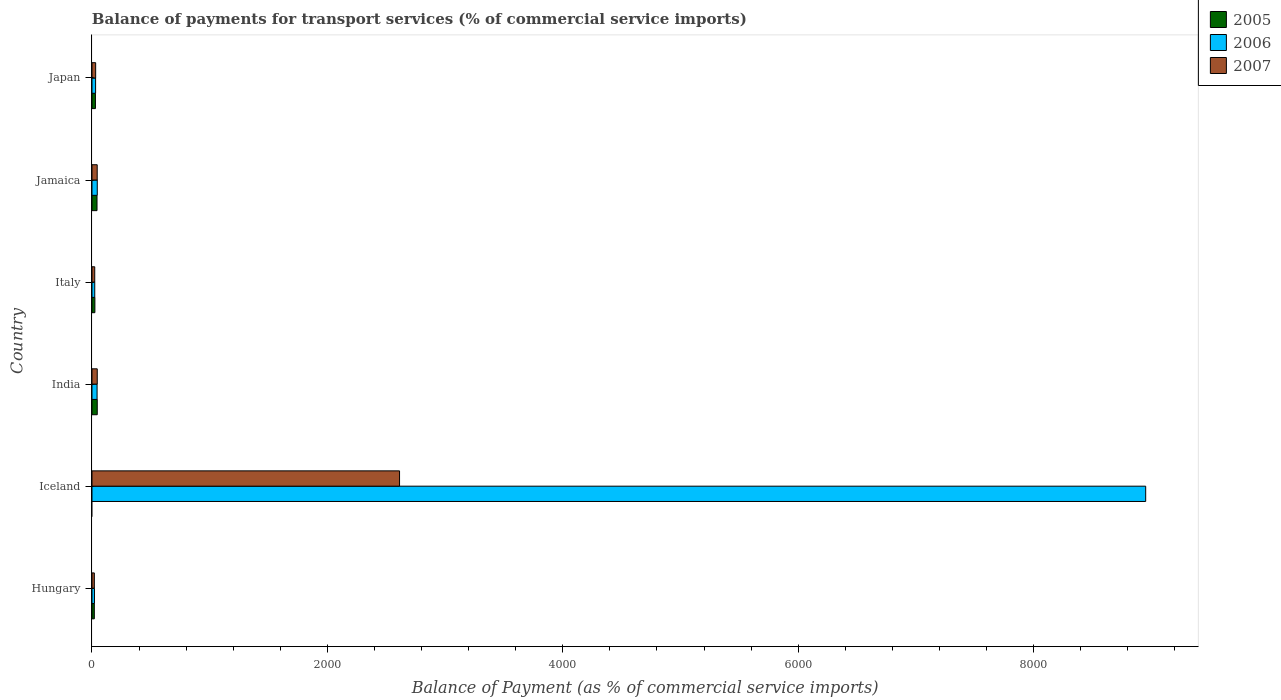How many different coloured bars are there?
Offer a very short reply. 3. How many groups of bars are there?
Provide a succinct answer. 6. Are the number of bars per tick equal to the number of legend labels?
Make the answer very short. No. What is the label of the 3rd group of bars from the top?
Offer a very short reply. Italy. In how many cases, is the number of bars for a given country not equal to the number of legend labels?
Provide a succinct answer. 1. What is the balance of payments for transport services in 2007 in Iceland?
Provide a succinct answer. 2613.27. Across all countries, what is the maximum balance of payments for transport services in 2007?
Your answer should be very brief. 2613.27. Across all countries, what is the minimum balance of payments for transport services in 2007?
Your response must be concise. 20.06. In which country was the balance of payments for transport services in 2007 maximum?
Your answer should be compact. Iceland. What is the total balance of payments for transport services in 2005 in the graph?
Keep it short and to the point. 161.64. What is the difference between the balance of payments for transport services in 2006 in India and that in Jamaica?
Your response must be concise. -1.61. What is the difference between the balance of payments for transport services in 2007 in India and the balance of payments for transport services in 2006 in Iceland?
Your response must be concise. -8907.91. What is the average balance of payments for transport services in 2006 per country?
Your answer should be compact. 1519.38. What is the difference between the balance of payments for transport services in 2006 and balance of payments for transport services in 2005 in Hungary?
Keep it short and to the point. 1.21. What is the ratio of the balance of payments for transport services in 2006 in India to that in Japan?
Offer a terse response. 1.41. Is the balance of payments for transport services in 2005 in Hungary less than that in Jamaica?
Provide a short and direct response. Yes. What is the difference between the highest and the second highest balance of payments for transport services in 2007?
Give a very brief answer. 2568.44. What is the difference between the highest and the lowest balance of payments for transport services in 2006?
Provide a short and direct response. 8931.58. Is it the case that in every country, the sum of the balance of payments for transport services in 2005 and balance of payments for transport services in 2007 is greater than the balance of payments for transport services in 2006?
Provide a short and direct response. No. How many bars are there?
Provide a succinct answer. 17. How many countries are there in the graph?
Offer a very short reply. 6. Does the graph contain grids?
Keep it short and to the point. No. How many legend labels are there?
Ensure brevity in your answer.  3. How are the legend labels stacked?
Give a very brief answer. Vertical. What is the title of the graph?
Give a very brief answer. Balance of payments for transport services (% of commercial service imports). Does "1967" appear as one of the legend labels in the graph?
Provide a short and direct response. No. What is the label or title of the X-axis?
Offer a terse response. Balance of Payment (as % of commercial service imports). What is the label or title of the Y-axis?
Offer a terse response. Country. What is the Balance of Payment (as % of commercial service imports) in 2005 in Hungary?
Offer a very short reply. 19.94. What is the Balance of Payment (as % of commercial service imports) in 2006 in Hungary?
Your answer should be compact. 21.15. What is the Balance of Payment (as % of commercial service imports) of 2007 in Hungary?
Your answer should be compact. 20.06. What is the Balance of Payment (as % of commercial service imports) in 2005 in Iceland?
Give a very brief answer. 0. What is the Balance of Payment (as % of commercial service imports) of 2006 in Iceland?
Your answer should be very brief. 8952.73. What is the Balance of Payment (as % of commercial service imports) of 2007 in Iceland?
Ensure brevity in your answer.  2613.27. What is the Balance of Payment (as % of commercial service imports) in 2005 in India?
Your answer should be compact. 44.73. What is the Balance of Payment (as % of commercial service imports) of 2006 in India?
Offer a terse response. 43.35. What is the Balance of Payment (as % of commercial service imports) in 2007 in India?
Keep it short and to the point. 44.82. What is the Balance of Payment (as % of commercial service imports) of 2005 in Italy?
Provide a short and direct response. 24.75. What is the Balance of Payment (as % of commercial service imports) of 2006 in Italy?
Ensure brevity in your answer.  23.47. What is the Balance of Payment (as % of commercial service imports) in 2007 in Italy?
Ensure brevity in your answer.  23.34. What is the Balance of Payment (as % of commercial service imports) in 2005 in Jamaica?
Make the answer very short. 42.83. What is the Balance of Payment (as % of commercial service imports) of 2006 in Jamaica?
Offer a very short reply. 44.96. What is the Balance of Payment (as % of commercial service imports) in 2007 in Jamaica?
Your response must be concise. 44.37. What is the Balance of Payment (as % of commercial service imports) in 2005 in Japan?
Keep it short and to the point. 29.4. What is the Balance of Payment (as % of commercial service imports) of 2006 in Japan?
Offer a very short reply. 30.65. What is the Balance of Payment (as % of commercial service imports) in 2007 in Japan?
Give a very brief answer. 31.23. Across all countries, what is the maximum Balance of Payment (as % of commercial service imports) in 2005?
Make the answer very short. 44.73. Across all countries, what is the maximum Balance of Payment (as % of commercial service imports) of 2006?
Your response must be concise. 8952.73. Across all countries, what is the maximum Balance of Payment (as % of commercial service imports) in 2007?
Keep it short and to the point. 2613.27. Across all countries, what is the minimum Balance of Payment (as % of commercial service imports) of 2006?
Make the answer very short. 21.15. Across all countries, what is the minimum Balance of Payment (as % of commercial service imports) of 2007?
Offer a terse response. 20.06. What is the total Balance of Payment (as % of commercial service imports) of 2005 in the graph?
Provide a succinct answer. 161.64. What is the total Balance of Payment (as % of commercial service imports) in 2006 in the graph?
Provide a succinct answer. 9116.3. What is the total Balance of Payment (as % of commercial service imports) of 2007 in the graph?
Provide a succinct answer. 2777.1. What is the difference between the Balance of Payment (as % of commercial service imports) of 2006 in Hungary and that in Iceland?
Your response must be concise. -8931.58. What is the difference between the Balance of Payment (as % of commercial service imports) of 2007 in Hungary and that in Iceland?
Ensure brevity in your answer.  -2593.2. What is the difference between the Balance of Payment (as % of commercial service imports) in 2005 in Hungary and that in India?
Provide a short and direct response. -24.79. What is the difference between the Balance of Payment (as % of commercial service imports) of 2006 in Hungary and that in India?
Offer a very short reply. -22.2. What is the difference between the Balance of Payment (as % of commercial service imports) in 2007 in Hungary and that in India?
Provide a succinct answer. -24.76. What is the difference between the Balance of Payment (as % of commercial service imports) of 2005 in Hungary and that in Italy?
Your answer should be compact. -4.81. What is the difference between the Balance of Payment (as % of commercial service imports) in 2006 in Hungary and that in Italy?
Provide a short and direct response. -2.32. What is the difference between the Balance of Payment (as % of commercial service imports) in 2007 in Hungary and that in Italy?
Make the answer very short. -3.27. What is the difference between the Balance of Payment (as % of commercial service imports) of 2005 in Hungary and that in Jamaica?
Offer a terse response. -22.89. What is the difference between the Balance of Payment (as % of commercial service imports) in 2006 in Hungary and that in Jamaica?
Your answer should be compact. -23.81. What is the difference between the Balance of Payment (as % of commercial service imports) of 2007 in Hungary and that in Jamaica?
Offer a very short reply. -24.31. What is the difference between the Balance of Payment (as % of commercial service imports) in 2005 in Hungary and that in Japan?
Make the answer very short. -9.46. What is the difference between the Balance of Payment (as % of commercial service imports) of 2006 in Hungary and that in Japan?
Make the answer very short. -9.5. What is the difference between the Balance of Payment (as % of commercial service imports) in 2007 in Hungary and that in Japan?
Provide a short and direct response. -11.17. What is the difference between the Balance of Payment (as % of commercial service imports) of 2006 in Iceland and that in India?
Offer a very short reply. 8909.38. What is the difference between the Balance of Payment (as % of commercial service imports) in 2007 in Iceland and that in India?
Your answer should be compact. 2568.44. What is the difference between the Balance of Payment (as % of commercial service imports) in 2006 in Iceland and that in Italy?
Provide a short and direct response. 8929.26. What is the difference between the Balance of Payment (as % of commercial service imports) of 2007 in Iceland and that in Italy?
Keep it short and to the point. 2589.93. What is the difference between the Balance of Payment (as % of commercial service imports) of 2006 in Iceland and that in Jamaica?
Provide a succinct answer. 8907.77. What is the difference between the Balance of Payment (as % of commercial service imports) in 2007 in Iceland and that in Jamaica?
Provide a short and direct response. 2568.89. What is the difference between the Balance of Payment (as % of commercial service imports) in 2006 in Iceland and that in Japan?
Provide a short and direct response. 8922.08. What is the difference between the Balance of Payment (as % of commercial service imports) in 2007 in Iceland and that in Japan?
Offer a very short reply. 2582.03. What is the difference between the Balance of Payment (as % of commercial service imports) of 2005 in India and that in Italy?
Your response must be concise. 19.98. What is the difference between the Balance of Payment (as % of commercial service imports) of 2006 in India and that in Italy?
Your response must be concise. 19.88. What is the difference between the Balance of Payment (as % of commercial service imports) of 2007 in India and that in Italy?
Make the answer very short. 21.49. What is the difference between the Balance of Payment (as % of commercial service imports) in 2005 in India and that in Jamaica?
Provide a succinct answer. 1.89. What is the difference between the Balance of Payment (as % of commercial service imports) in 2006 in India and that in Jamaica?
Keep it short and to the point. -1.61. What is the difference between the Balance of Payment (as % of commercial service imports) in 2007 in India and that in Jamaica?
Provide a short and direct response. 0.45. What is the difference between the Balance of Payment (as % of commercial service imports) in 2005 in India and that in Japan?
Offer a very short reply. 15.33. What is the difference between the Balance of Payment (as % of commercial service imports) in 2006 in India and that in Japan?
Ensure brevity in your answer.  12.7. What is the difference between the Balance of Payment (as % of commercial service imports) of 2007 in India and that in Japan?
Offer a terse response. 13.59. What is the difference between the Balance of Payment (as % of commercial service imports) of 2005 in Italy and that in Jamaica?
Your answer should be very brief. -18.09. What is the difference between the Balance of Payment (as % of commercial service imports) in 2006 in Italy and that in Jamaica?
Provide a succinct answer. -21.49. What is the difference between the Balance of Payment (as % of commercial service imports) of 2007 in Italy and that in Jamaica?
Your answer should be very brief. -21.04. What is the difference between the Balance of Payment (as % of commercial service imports) of 2005 in Italy and that in Japan?
Offer a terse response. -4.65. What is the difference between the Balance of Payment (as % of commercial service imports) in 2006 in Italy and that in Japan?
Give a very brief answer. -7.18. What is the difference between the Balance of Payment (as % of commercial service imports) in 2007 in Italy and that in Japan?
Ensure brevity in your answer.  -7.9. What is the difference between the Balance of Payment (as % of commercial service imports) of 2005 in Jamaica and that in Japan?
Offer a terse response. 13.44. What is the difference between the Balance of Payment (as % of commercial service imports) in 2006 in Jamaica and that in Japan?
Your answer should be compact. 14.31. What is the difference between the Balance of Payment (as % of commercial service imports) of 2007 in Jamaica and that in Japan?
Offer a terse response. 13.14. What is the difference between the Balance of Payment (as % of commercial service imports) of 2005 in Hungary and the Balance of Payment (as % of commercial service imports) of 2006 in Iceland?
Make the answer very short. -8932.79. What is the difference between the Balance of Payment (as % of commercial service imports) of 2005 in Hungary and the Balance of Payment (as % of commercial service imports) of 2007 in Iceland?
Provide a short and direct response. -2593.33. What is the difference between the Balance of Payment (as % of commercial service imports) in 2006 in Hungary and the Balance of Payment (as % of commercial service imports) in 2007 in Iceland?
Offer a terse response. -2592.12. What is the difference between the Balance of Payment (as % of commercial service imports) of 2005 in Hungary and the Balance of Payment (as % of commercial service imports) of 2006 in India?
Give a very brief answer. -23.41. What is the difference between the Balance of Payment (as % of commercial service imports) of 2005 in Hungary and the Balance of Payment (as % of commercial service imports) of 2007 in India?
Your answer should be very brief. -24.88. What is the difference between the Balance of Payment (as % of commercial service imports) of 2006 in Hungary and the Balance of Payment (as % of commercial service imports) of 2007 in India?
Provide a short and direct response. -23.68. What is the difference between the Balance of Payment (as % of commercial service imports) in 2005 in Hungary and the Balance of Payment (as % of commercial service imports) in 2006 in Italy?
Your answer should be compact. -3.53. What is the difference between the Balance of Payment (as % of commercial service imports) of 2005 in Hungary and the Balance of Payment (as % of commercial service imports) of 2007 in Italy?
Give a very brief answer. -3.4. What is the difference between the Balance of Payment (as % of commercial service imports) of 2006 in Hungary and the Balance of Payment (as % of commercial service imports) of 2007 in Italy?
Provide a succinct answer. -2.19. What is the difference between the Balance of Payment (as % of commercial service imports) of 2005 in Hungary and the Balance of Payment (as % of commercial service imports) of 2006 in Jamaica?
Keep it short and to the point. -25.02. What is the difference between the Balance of Payment (as % of commercial service imports) of 2005 in Hungary and the Balance of Payment (as % of commercial service imports) of 2007 in Jamaica?
Offer a very short reply. -24.43. What is the difference between the Balance of Payment (as % of commercial service imports) in 2006 in Hungary and the Balance of Payment (as % of commercial service imports) in 2007 in Jamaica?
Provide a succinct answer. -23.23. What is the difference between the Balance of Payment (as % of commercial service imports) of 2005 in Hungary and the Balance of Payment (as % of commercial service imports) of 2006 in Japan?
Give a very brief answer. -10.71. What is the difference between the Balance of Payment (as % of commercial service imports) in 2005 in Hungary and the Balance of Payment (as % of commercial service imports) in 2007 in Japan?
Make the answer very short. -11.3. What is the difference between the Balance of Payment (as % of commercial service imports) of 2006 in Hungary and the Balance of Payment (as % of commercial service imports) of 2007 in Japan?
Provide a short and direct response. -10.09. What is the difference between the Balance of Payment (as % of commercial service imports) in 2006 in Iceland and the Balance of Payment (as % of commercial service imports) in 2007 in India?
Provide a succinct answer. 8907.91. What is the difference between the Balance of Payment (as % of commercial service imports) of 2006 in Iceland and the Balance of Payment (as % of commercial service imports) of 2007 in Italy?
Give a very brief answer. 8929.39. What is the difference between the Balance of Payment (as % of commercial service imports) in 2006 in Iceland and the Balance of Payment (as % of commercial service imports) in 2007 in Jamaica?
Your answer should be very brief. 8908.36. What is the difference between the Balance of Payment (as % of commercial service imports) in 2006 in Iceland and the Balance of Payment (as % of commercial service imports) in 2007 in Japan?
Offer a very short reply. 8921.49. What is the difference between the Balance of Payment (as % of commercial service imports) of 2005 in India and the Balance of Payment (as % of commercial service imports) of 2006 in Italy?
Keep it short and to the point. 21.26. What is the difference between the Balance of Payment (as % of commercial service imports) of 2005 in India and the Balance of Payment (as % of commercial service imports) of 2007 in Italy?
Offer a very short reply. 21.39. What is the difference between the Balance of Payment (as % of commercial service imports) in 2006 in India and the Balance of Payment (as % of commercial service imports) in 2007 in Italy?
Provide a succinct answer. 20.01. What is the difference between the Balance of Payment (as % of commercial service imports) of 2005 in India and the Balance of Payment (as % of commercial service imports) of 2006 in Jamaica?
Give a very brief answer. -0.23. What is the difference between the Balance of Payment (as % of commercial service imports) of 2005 in India and the Balance of Payment (as % of commercial service imports) of 2007 in Jamaica?
Your answer should be compact. 0.35. What is the difference between the Balance of Payment (as % of commercial service imports) of 2006 in India and the Balance of Payment (as % of commercial service imports) of 2007 in Jamaica?
Your answer should be compact. -1.03. What is the difference between the Balance of Payment (as % of commercial service imports) of 2005 in India and the Balance of Payment (as % of commercial service imports) of 2006 in Japan?
Keep it short and to the point. 14.07. What is the difference between the Balance of Payment (as % of commercial service imports) of 2005 in India and the Balance of Payment (as % of commercial service imports) of 2007 in Japan?
Provide a short and direct response. 13.49. What is the difference between the Balance of Payment (as % of commercial service imports) in 2006 in India and the Balance of Payment (as % of commercial service imports) in 2007 in Japan?
Give a very brief answer. 12.11. What is the difference between the Balance of Payment (as % of commercial service imports) in 2005 in Italy and the Balance of Payment (as % of commercial service imports) in 2006 in Jamaica?
Provide a short and direct response. -20.21. What is the difference between the Balance of Payment (as % of commercial service imports) in 2005 in Italy and the Balance of Payment (as % of commercial service imports) in 2007 in Jamaica?
Give a very brief answer. -19.63. What is the difference between the Balance of Payment (as % of commercial service imports) in 2006 in Italy and the Balance of Payment (as % of commercial service imports) in 2007 in Jamaica?
Give a very brief answer. -20.9. What is the difference between the Balance of Payment (as % of commercial service imports) of 2005 in Italy and the Balance of Payment (as % of commercial service imports) of 2006 in Japan?
Keep it short and to the point. -5.9. What is the difference between the Balance of Payment (as % of commercial service imports) of 2005 in Italy and the Balance of Payment (as % of commercial service imports) of 2007 in Japan?
Offer a very short reply. -6.49. What is the difference between the Balance of Payment (as % of commercial service imports) of 2006 in Italy and the Balance of Payment (as % of commercial service imports) of 2007 in Japan?
Ensure brevity in your answer.  -7.77. What is the difference between the Balance of Payment (as % of commercial service imports) of 2005 in Jamaica and the Balance of Payment (as % of commercial service imports) of 2006 in Japan?
Your answer should be very brief. 12.18. What is the difference between the Balance of Payment (as % of commercial service imports) of 2005 in Jamaica and the Balance of Payment (as % of commercial service imports) of 2007 in Japan?
Give a very brief answer. 11.6. What is the difference between the Balance of Payment (as % of commercial service imports) in 2006 in Jamaica and the Balance of Payment (as % of commercial service imports) in 2007 in Japan?
Ensure brevity in your answer.  13.72. What is the average Balance of Payment (as % of commercial service imports) of 2005 per country?
Your answer should be compact. 26.94. What is the average Balance of Payment (as % of commercial service imports) of 2006 per country?
Your answer should be compact. 1519.38. What is the average Balance of Payment (as % of commercial service imports) in 2007 per country?
Give a very brief answer. 462.85. What is the difference between the Balance of Payment (as % of commercial service imports) of 2005 and Balance of Payment (as % of commercial service imports) of 2006 in Hungary?
Offer a very short reply. -1.21. What is the difference between the Balance of Payment (as % of commercial service imports) of 2005 and Balance of Payment (as % of commercial service imports) of 2007 in Hungary?
Provide a short and direct response. -0.12. What is the difference between the Balance of Payment (as % of commercial service imports) of 2006 and Balance of Payment (as % of commercial service imports) of 2007 in Hungary?
Your answer should be very brief. 1.08. What is the difference between the Balance of Payment (as % of commercial service imports) in 2006 and Balance of Payment (as % of commercial service imports) in 2007 in Iceland?
Your answer should be very brief. 6339.46. What is the difference between the Balance of Payment (as % of commercial service imports) in 2005 and Balance of Payment (as % of commercial service imports) in 2006 in India?
Provide a short and direct response. 1.38. What is the difference between the Balance of Payment (as % of commercial service imports) of 2005 and Balance of Payment (as % of commercial service imports) of 2007 in India?
Make the answer very short. -0.1. What is the difference between the Balance of Payment (as % of commercial service imports) in 2006 and Balance of Payment (as % of commercial service imports) in 2007 in India?
Provide a short and direct response. -1.48. What is the difference between the Balance of Payment (as % of commercial service imports) of 2005 and Balance of Payment (as % of commercial service imports) of 2006 in Italy?
Your answer should be very brief. 1.28. What is the difference between the Balance of Payment (as % of commercial service imports) in 2005 and Balance of Payment (as % of commercial service imports) in 2007 in Italy?
Keep it short and to the point. 1.41. What is the difference between the Balance of Payment (as % of commercial service imports) of 2006 and Balance of Payment (as % of commercial service imports) of 2007 in Italy?
Your answer should be very brief. 0.13. What is the difference between the Balance of Payment (as % of commercial service imports) of 2005 and Balance of Payment (as % of commercial service imports) of 2006 in Jamaica?
Your answer should be very brief. -2.12. What is the difference between the Balance of Payment (as % of commercial service imports) of 2005 and Balance of Payment (as % of commercial service imports) of 2007 in Jamaica?
Your answer should be compact. -1.54. What is the difference between the Balance of Payment (as % of commercial service imports) of 2006 and Balance of Payment (as % of commercial service imports) of 2007 in Jamaica?
Keep it short and to the point. 0.58. What is the difference between the Balance of Payment (as % of commercial service imports) of 2005 and Balance of Payment (as % of commercial service imports) of 2006 in Japan?
Your answer should be compact. -1.26. What is the difference between the Balance of Payment (as % of commercial service imports) of 2005 and Balance of Payment (as % of commercial service imports) of 2007 in Japan?
Give a very brief answer. -1.84. What is the difference between the Balance of Payment (as % of commercial service imports) of 2006 and Balance of Payment (as % of commercial service imports) of 2007 in Japan?
Your response must be concise. -0.58. What is the ratio of the Balance of Payment (as % of commercial service imports) of 2006 in Hungary to that in Iceland?
Offer a terse response. 0. What is the ratio of the Balance of Payment (as % of commercial service imports) in 2007 in Hungary to that in Iceland?
Offer a terse response. 0.01. What is the ratio of the Balance of Payment (as % of commercial service imports) of 2005 in Hungary to that in India?
Your response must be concise. 0.45. What is the ratio of the Balance of Payment (as % of commercial service imports) of 2006 in Hungary to that in India?
Provide a succinct answer. 0.49. What is the ratio of the Balance of Payment (as % of commercial service imports) of 2007 in Hungary to that in India?
Give a very brief answer. 0.45. What is the ratio of the Balance of Payment (as % of commercial service imports) of 2005 in Hungary to that in Italy?
Give a very brief answer. 0.81. What is the ratio of the Balance of Payment (as % of commercial service imports) in 2006 in Hungary to that in Italy?
Provide a succinct answer. 0.9. What is the ratio of the Balance of Payment (as % of commercial service imports) of 2007 in Hungary to that in Italy?
Offer a very short reply. 0.86. What is the ratio of the Balance of Payment (as % of commercial service imports) in 2005 in Hungary to that in Jamaica?
Ensure brevity in your answer.  0.47. What is the ratio of the Balance of Payment (as % of commercial service imports) in 2006 in Hungary to that in Jamaica?
Provide a succinct answer. 0.47. What is the ratio of the Balance of Payment (as % of commercial service imports) in 2007 in Hungary to that in Jamaica?
Make the answer very short. 0.45. What is the ratio of the Balance of Payment (as % of commercial service imports) in 2005 in Hungary to that in Japan?
Ensure brevity in your answer.  0.68. What is the ratio of the Balance of Payment (as % of commercial service imports) of 2006 in Hungary to that in Japan?
Offer a very short reply. 0.69. What is the ratio of the Balance of Payment (as % of commercial service imports) in 2007 in Hungary to that in Japan?
Your answer should be very brief. 0.64. What is the ratio of the Balance of Payment (as % of commercial service imports) of 2006 in Iceland to that in India?
Make the answer very short. 206.53. What is the ratio of the Balance of Payment (as % of commercial service imports) in 2007 in Iceland to that in India?
Give a very brief answer. 58.3. What is the ratio of the Balance of Payment (as % of commercial service imports) in 2006 in Iceland to that in Italy?
Your response must be concise. 381.47. What is the ratio of the Balance of Payment (as % of commercial service imports) of 2007 in Iceland to that in Italy?
Your answer should be very brief. 111.99. What is the ratio of the Balance of Payment (as % of commercial service imports) in 2006 in Iceland to that in Jamaica?
Provide a short and direct response. 199.14. What is the ratio of the Balance of Payment (as % of commercial service imports) of 2007 in Iceland to that in Jamaica?
Your response must be concise. 58.89. What is the ratio of the Balance of Payment (as % of commercial service imports) of 2006 in Iceland to that in Japan?
Provide a short and direct response. 292.08. What is the ratio of the Balance of Payment (as % of commercial service imports) in 2007 in Iceland to that in Japan?
Your answer should be very brief. 83.67. What is the ratio of the Balance of Payment (as % of commercial service imports) of 2005 in India to that in Italy?
Offer a terse response. 1.81. What is the ratio of the Balance of Payment (as % of commercial service imports) of 2006 in India to that in Italy?
Offer a terse response. 1.85. What is the ratio of the Balance of Payment (as % of commercial service imports) of 2007 in India to that in Italy?
Offer a terse response. 1.92. What is the ratio of the Balance of Payment (as % of commercial service imports) of 2005 in India to that in Jamaica?
Your answer should be compact. 1.04. What is the ratio of the Balance of Payment (as % of commercial service imports) of 2006 in India to that in Jamaica?
Give a very brief answer. 0.96. What is the ratio of the Balance of Payment (as % of commercial service imports) in 2007 in India to that in Jamaica?
Make the answer very short. 1.01. What is the ratio of the Balance of Payment (as % of commercial service imports) of 2005 in India to that in Japan?
Your answer should be very brief. 1.52. What is the ratio of the Balance of Payment (as % of commercial service imports) of 2006 in India to that in Japan?
Give a very brief answer. 1.41. What is the ratio of the Balance of Payment (as % of commercial service imports) in 2007 in India to that in Japan?
Make the answer very short. 1.44. What is the ratio of the Balance of Payment (as % of commercial service imports) in 2005 in Italy to that in Jamaica?
Ensure brevity in your answer.  0.58. What is the ratio of the Balance of Payment (as % of commercial service imports) in 2006 in Italy to that in Jamaica?
Your answer should be very brief. 0.52. What is the ratio of the Balance of Payment (as % of commercial service imports) of 2007 in Italy to that in Jamaica?
Your response must be concise. 0.53. What is the ratio of the Balance of Payment (as % of commercial service imports) in 2005 in Italy to that in Japan?
Your answer should be very brief. 0.84. What is the ratio of the Balance of Payment (as % of commercial service imports) of 2006 in Italy to that in Japan?
Your answer should be very brief. 0.77. What is the ratio of the Balance of Payment (as % of commercial service imports) of 2007 in Italy to that in Japan?
Offer a terse response. 0.75. What is the ratio of the Balance of Payment (as % of commercial service imports) of 2005 in Jamaica to that in Japan?
Offer a very short reply. 1.46. What is the ratio of the Balance of Payment (as % of commercial service imports) in 2006 in Jamaica to that in Japan?
Your answer should be very brief. 1.47. What is the ratio of the Balance of Payment (as % of commercial service imports) in 2007 in Jamaica to that in Japan?
Your response must be concise. 1.42. What is the difference between the highest and the second highest Balance of Payment (as % of commercial service imports) in 2005?
Offer a terse response. 1.89. What is the difference between the highest and the second highest Balance of Payment (as % of commercial service imports) of 2006?
Ensure brevity in your answer.  8907.77. What is the difference between the highest and the second highest Balance of Payment (as % of commercial service imports) in 2007?
Provide a short and direct response. 2568.44. What is the difference between the highest and the lowest Balance of Payment (as % of commercial service imports) of 2005?
Offer a very short reply. 44.73. What is the difference between the highest and the lowest Balance of Payment (as % of commercial service imports) of 2006?
Offer a terse response. 8931.58. What is the difference between the highest and the lowest Balance of Payment (as % of commercial service imports) of 2007?
Offer a terse response. 2593.2. 